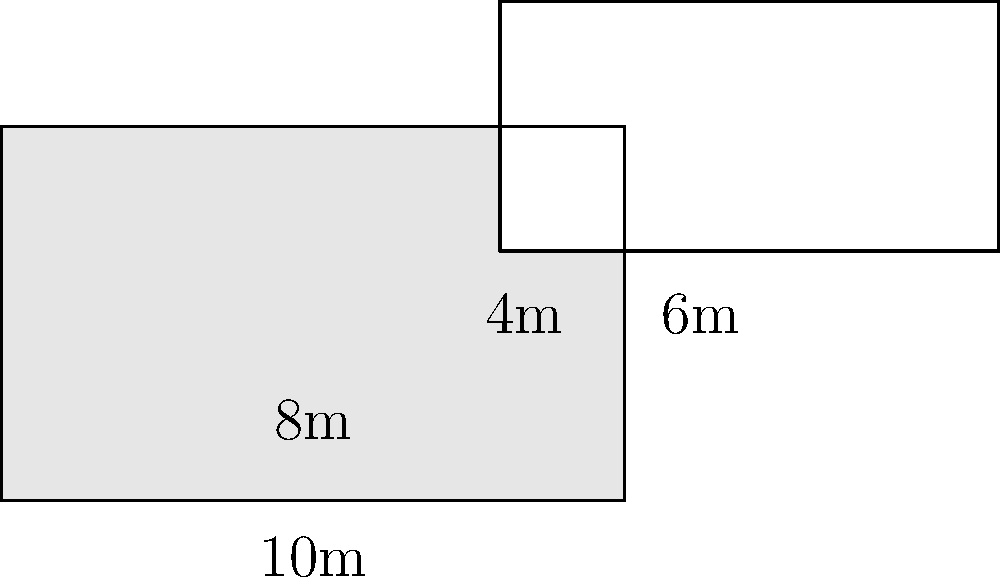As you evaluate the acoustics of a new concert hall, you notice its unique seating arrangement. The outer perimeter of the seating area forms a rectangle measuring 10m by 6m, while the inner stage area forms a centered rectangle of 8m by 4m. What is the area of the seating section, and what is its outer perimeter? To solve this problem, let's follow these steps:

1. Calculate the total area of the outer rectangle:
   $A_{outer} = 10m \times 6m = 60m^2$

2. Calculate the area of the inner rectangle (stage):
   $A_{inner} = 8m \times 4m = 32m^2$

3. Calculate the area of the seating section by subtracting the inner area from the outer area:
   $A_{seating} = A_{outer} - A_{inner} = 60m^2 - 32m^2 = 28m^2$

4. Calculate the outer perimeter of the seating area:
   $P_{outer} = 2(10m + 6m) = 2(16m) = 32m$

Therefore, the area of the seating section is $28m^2$, and its outer perimeter is $32m$.
Answer: Area: $28m^2$, Perimeter: $32m$ 